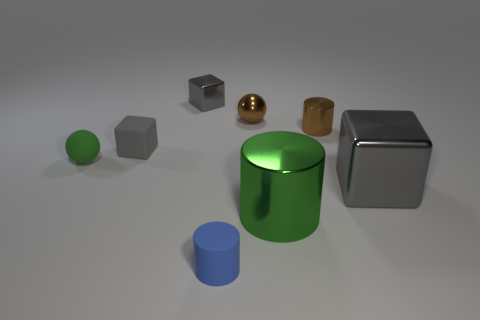How does the lighting in the image affect the mood or visual appeal? The lighting creates a soft and even ambiance, casting gentle shadows that give depth to the objects and contribute to the three-dimensional feel of the scene. The reflective surfaces of the shapes catch the light, adding a layer of visual interest and highlighting the textural differences between the objects. 